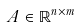<formula> <loc_0><loc_0><loc_500><loc_500>A \in \mathbb { R } ^ { n \times m }</formula> 